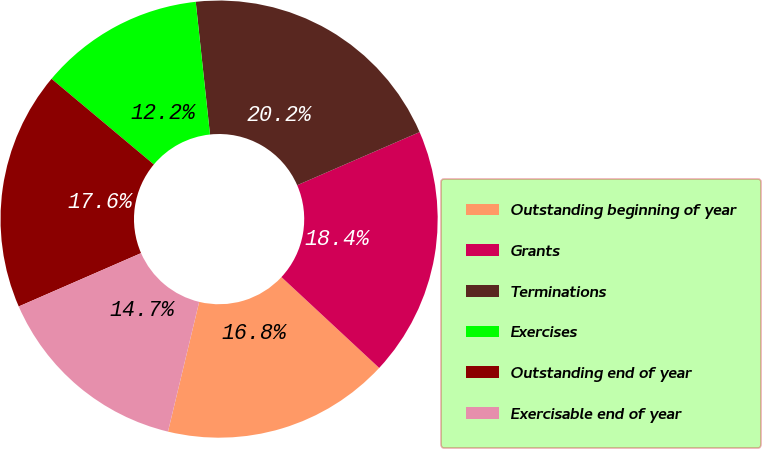Convert chart. <chart><loc_0><loc_0><loc_500><loc_500><pie_chart><fcel>Outstanding beginning of year<fcel>Grants<fcel>Terminations<fcel>Exercises<fcel>Outstanding end of year<fcel>Exercisable end of year<nl><fcel>16.84%<fcel>18.44%<fcel>20.19%<fcel>12.2%<fcel>17.64%<fcel>14.7%<nl></chart> 